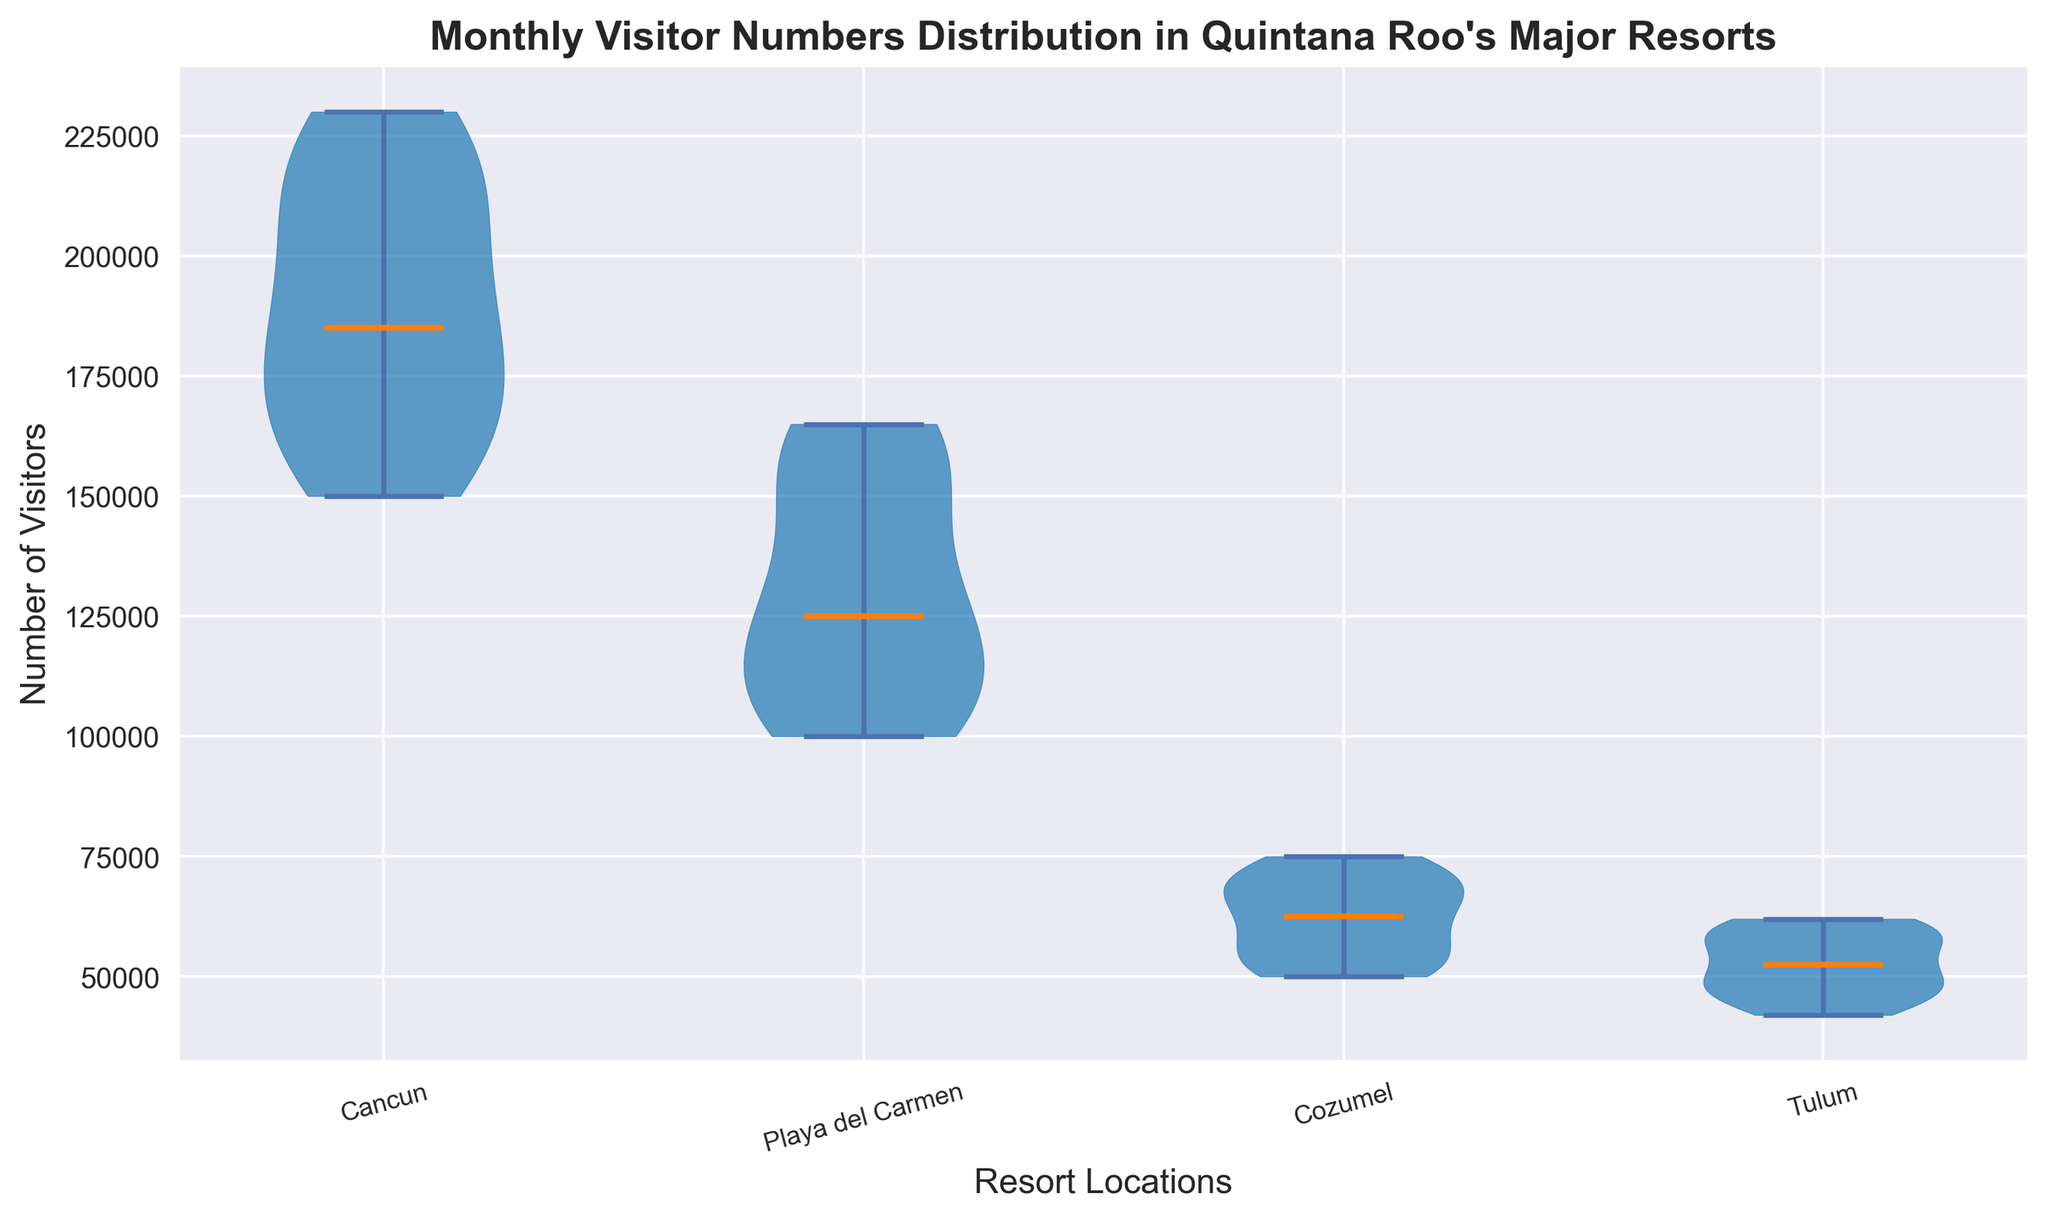Which resort location has the highest median visitor numbers? The median can be identified by looking at the horizontal line across the thickest part of each violin plot. The resort location with the highest horizontal median line is Cancun.
Answer: Cancun Which month has the lowest visitor numbers in Tulum? From the violin plot, we observe that the distribution is narrowest in September for Tulum, indicating it has the lowest median visitor numbers.
Answer: September What is the range of visitor numbers for Playa del Carmen? The range can be seen from the lowest to the highest points of the violin plot for Playa del Carmen. The minimal value is around 100,000, and the maximum is approximately 165,000.
Answer: 100,000 to 165,000 Between Cancun and Cozumel, which resort location shows the largest variation in visitor numbers? Variation is demonstrated by the width of the violin plot. Cancun's plot is wider compared to Cozumel's, indicating greater variation in visitor numbers.
Answer: Cancun Which resort has the most stable visitor numbers throughout the year? Stability is indicated by smaller range and narrower shape of the violin plot. Tulum's plot is the narrowest, signaling the most stable visitor numbers.
Answer: Tulum In which months do Cancun and Playa del Carmen have nearly equal visitor numbers? We have to compare the points where the respective violin plots overlap visually in height. They are nearly equal in October and November.
Answer: October, November What is the difference in median visitor numbers between March and September in Cancun? First, locate the median points for March and September in Cancun's violin plot. March has a higher median (220,000) compared to September (150,000). The difference is 220,000 - 150,000.
Answer: 70,000 How does the distribution of visitor numbers look in Cozumel compared to Playa del Carmen? By comparing the shapes of the violin plots, Cozumel has a much narrower and consistent distribution, whereas Playa del Carmen is broader and shows more variability in visitor numbers.
Answer: Cozumel is narrower, Playa del Carmen is broader 